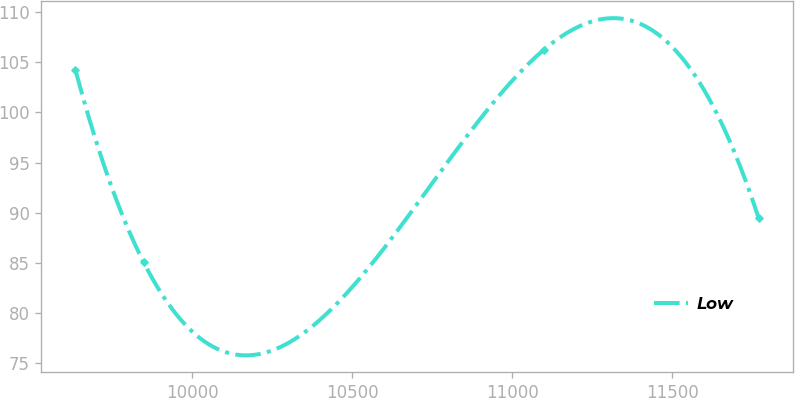Convert chart. <chart><loc_0><loc_0><loc_500><loc_500><line_chart><ecel><fcel>Low<nl><fcel>9634.93<fcel>104.27<nl><fcel>9848.4<fcel>85.04<nl><fcel>11097.8<fcel>106.23<nl><fcel>11769.6<fcel>89.49<nl></chart> 